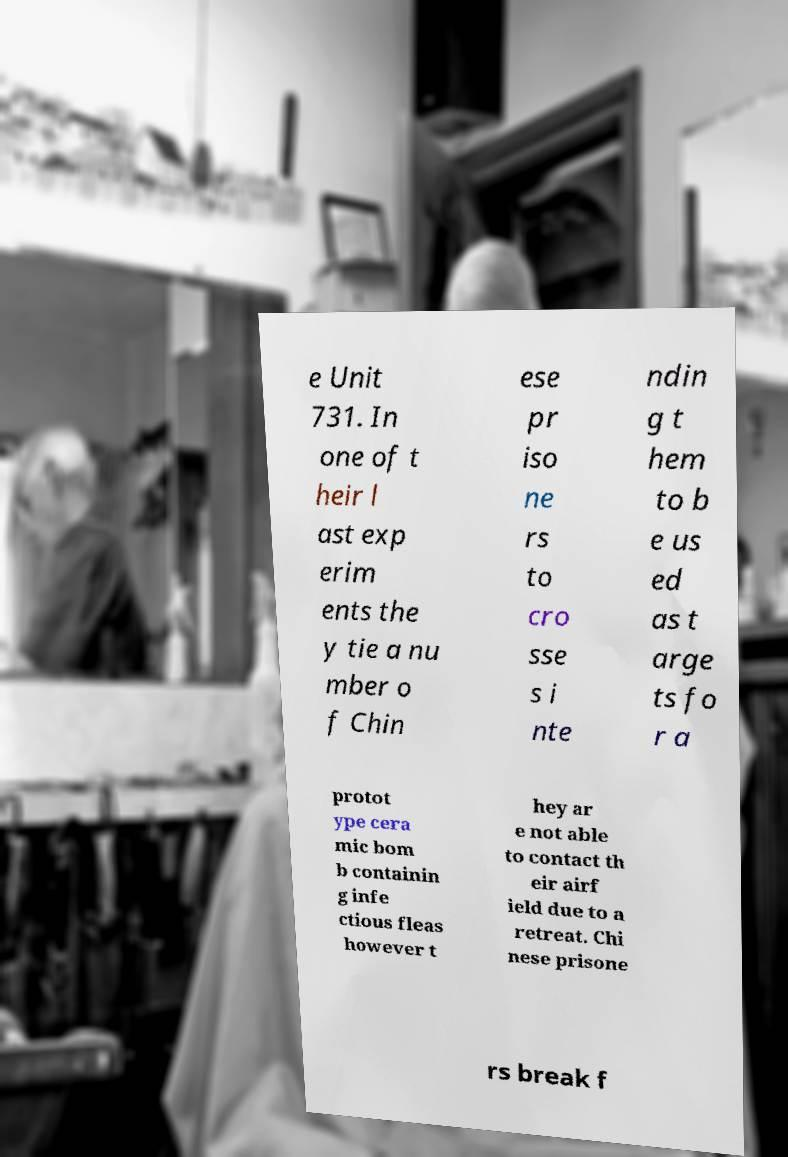Could you extract and type out the text from this image? e Unit 731. In one of t heir l ast exp erim ents the y tie a nu mber o f Chin ese pr iso ne rs to cro sse s i nte ndin g t hem to b e us ed as t arge ts fo r a protot ype cera mic bom b containin g infe ctious fleas however t hey ar e not able to contact th eir airf ield due to a retreat. Chi nese prisone rs break f 